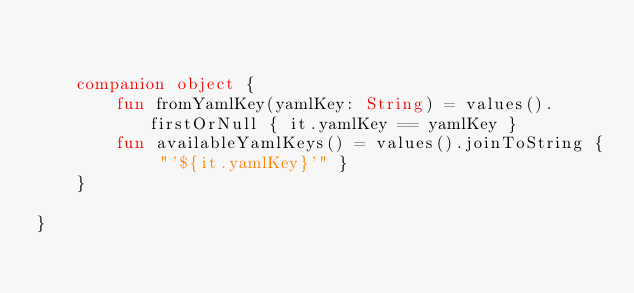<code> <loc_0><loc_0><loc_500><loc_500><_Kotlin_>

    companion object {
        fun fromYamlKey(yamlKey: String) = values().firstOrNull { it.yamlKey == yamlKey }
        fun availableYamlKeys() = values().joinToString { "'${it.yamlKey}'" }
    }

}</code> 